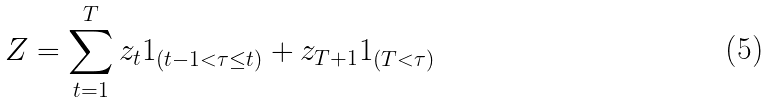<formula> <loc_0><loc_0><loc_500><loc_500>Z = \sum _ { t = 1 } ^ { T } z _ { t } 1 _ { ( t - 1 < \tau \leq t ) } + z _ { T + 1 } 1 _ { ( T < \tau ) }</formula> 